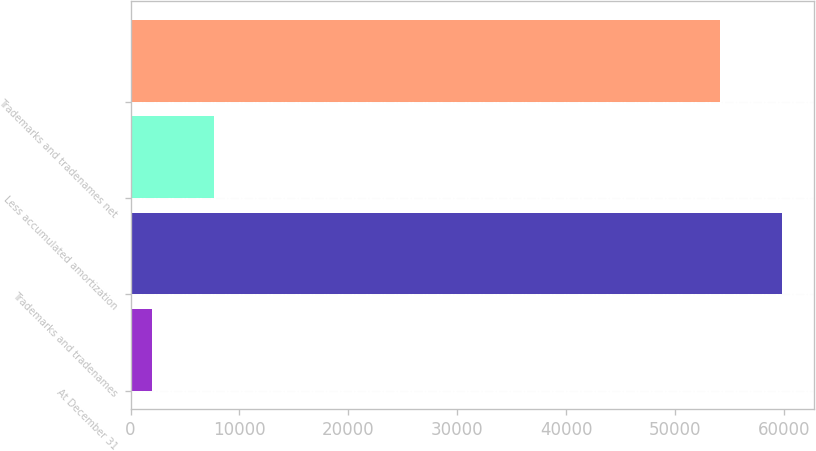<chart> <loc_0><loc_0><loc_500><loc_500><bar_chart><fcel>At December 31<fcel>Trademarks and tradenames<fcel>Less accumulated amortization<fcel>Trademarks and tradenames net<nl><fcel>2018<fcel>59785.3<fcel>7663.3<fcel>54140<nl></chart> 